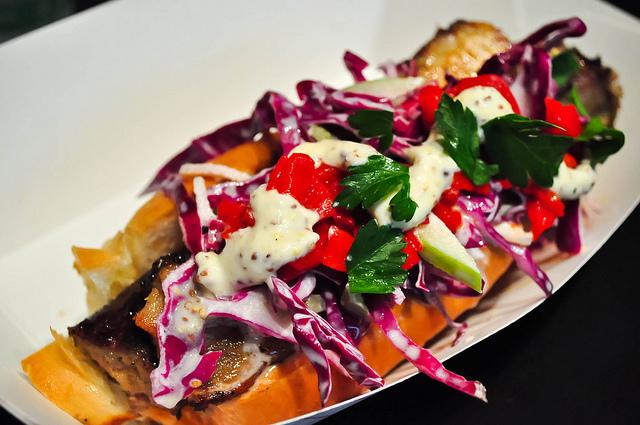Is the plate disposable?
Short answer required. Yes. What meal could this be eaten for?
Write a very short answer. Lunch. Are there lots of toppings?
Give a very brief answer. Yes. 